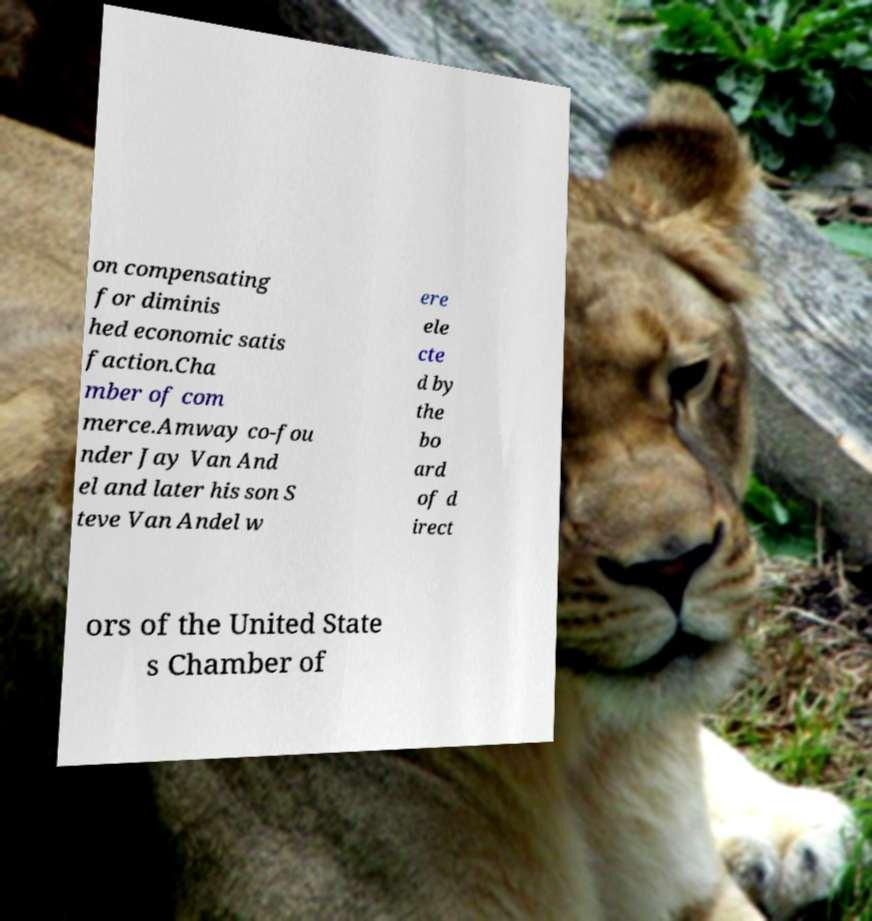Could you extract and type out the text from this image? on compensating for diminis hed economic satis faction.Cha mber of com merce.Amway co-fou nder Jay Van And el and later his son S teve Van Andel w ere ele cte d by the bo ard of d irect ors of the United State s Chamber of 